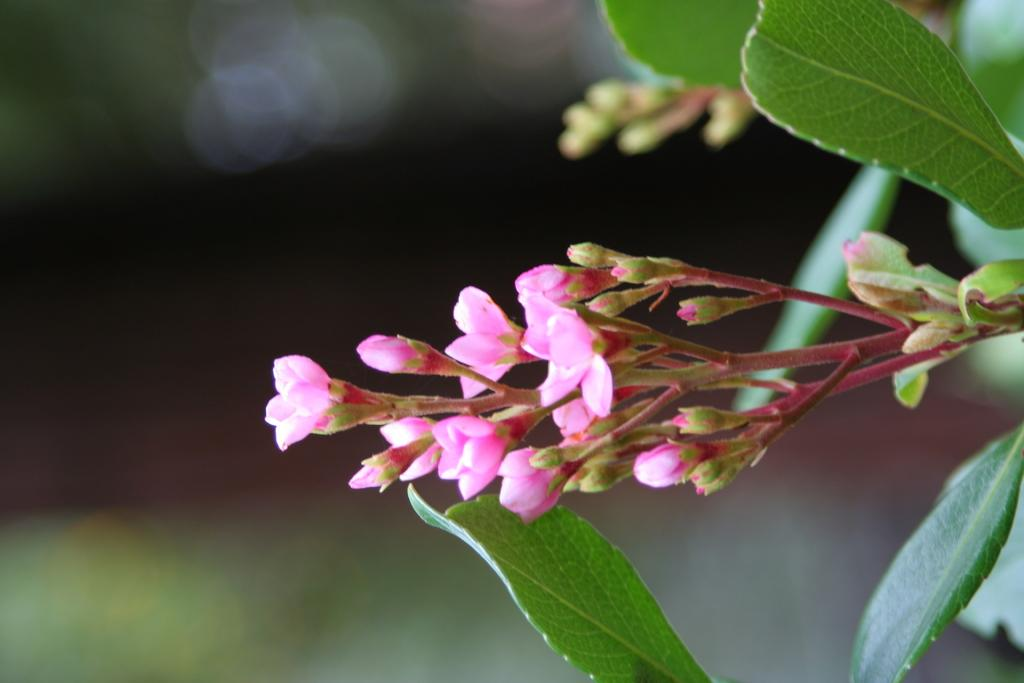What is the focus of the image? The image is zoomed in, so the focus is on a specific area or subject. What type of plant life can be seen in the image? There are flowers, buds, and leaves of a plant in the image. How would you describe the background of the image? The background of the image is blurry. What type of kettle is visible in the image? There is no kettle present in the image; it features plant life elements such as flowers, buds, and leaves. How does the distribution of the flowers in the image affect the overall composition? There is no information about the distribution of flowers in the image, as it is not mentioned in the provided facts. 